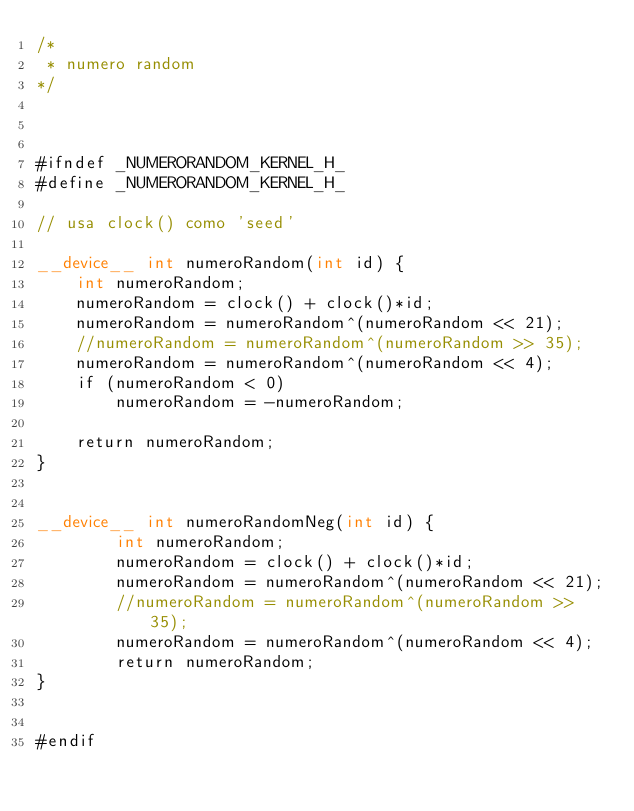Convert code to text. <code><loc_0><loc_0><loc_500><loc_500><_Cuda_>/*
 * numero random
*/



#ifndef _NUMERORANDOM_KERNEL_H_
#define _NUMERORANDOM_KERNEL_H_

// usa clock() como 'seed'

__device__ int numeroRandom(int id) {
	int numeroRandom;
	numeroRandom = clock() + clock()*id;
	numeroRandom = numeroRandom^(numeroRandom << 21);
	//numeroRandom = numeroRandom^(numeroRandom >> 35);
	numeroRandom = numeroRandom^(numeroRandom << 4);
	if (numeroRandom < 0)
		numeroRandom = -numeroRandom;

	return numeroRandom;
}


__device__ int numeroRandomNeg(int id) {
        int numeroRandom;
        numeroRandom = clock() + clock()*id;
        numeroRandom = numeroRandom^(numeroRandom << 21);
        //numeroRandom = numeroRandom^(numeroRandom >> 35);
        numeroRandom = numeroRandom^(numeroRandom << 4);
        return numeroRandom;
}


#endif
</code> 